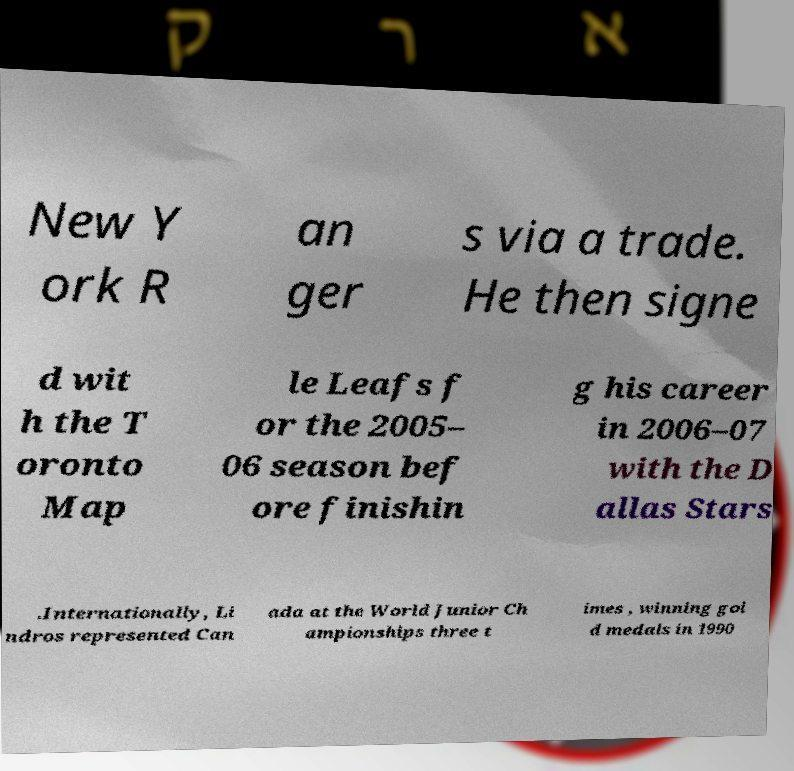Can you accurately transcribe the text from the provided image for me? New Y ork R an ger s via a trade. He then signe d wit h the T oronto Map le Leafs f or the 2005– 06 season bef ore finishin g his career in 2006–07 with the D allas Stars .Internationally, Li ndros represented Can ada at the World Junior Ch ampionships three t imes , winning gol d medals in 1990 